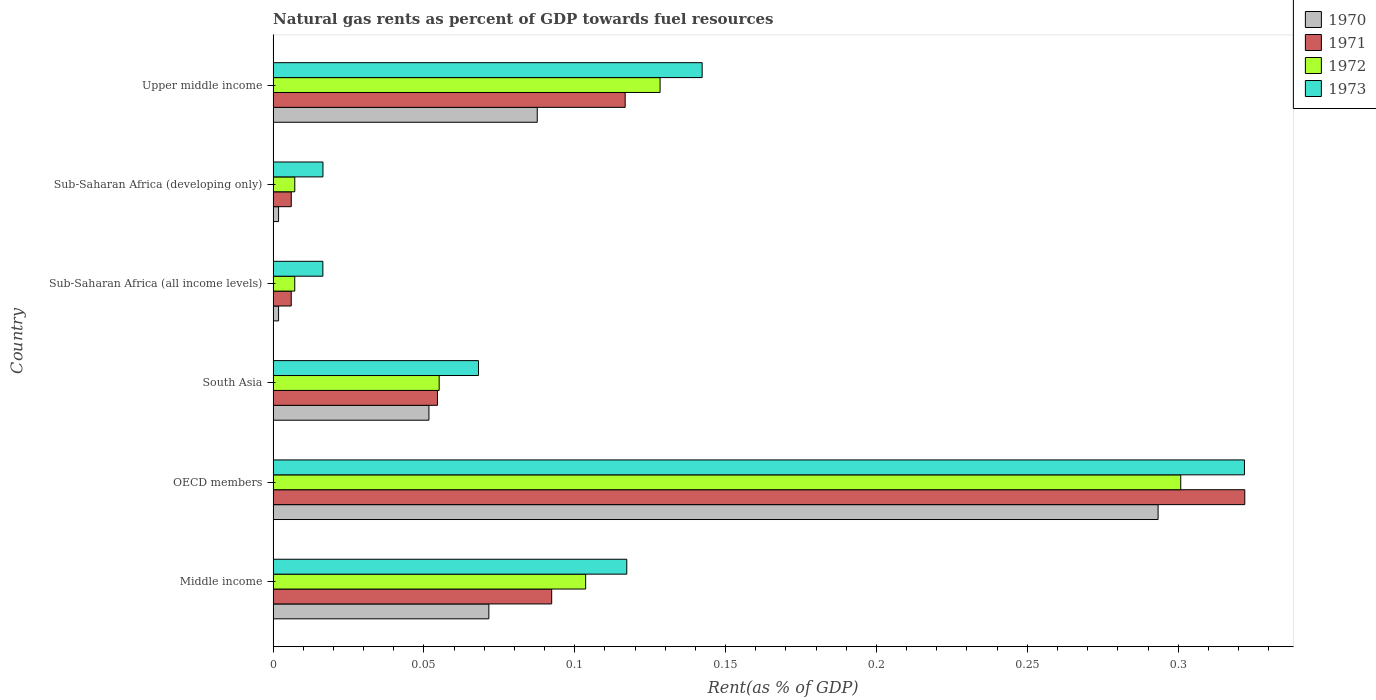Are the number of bars per tick equal to the number of legend labels?
Offer a terse response. Yes. Are the number of bars on each tick of the Y-axis equal?
Your response must be concise. Yes. How many bars are there on the 1st tick from the top?
Your response must be concise. 4. What is the label of the 2nd group of bars from the top?
Keep it short and to the point. Sub-Saharan Africa (developing only). What is the matural gas rent in 1972 in Sub-Saharan Africa (all income levels)?
Keep it short and to the point. 0.01. Across all countries, what is the maximum matural gas rent in 1971?
Keep it short and to the point. 0.32. Across all countries, what is the minimum matural gas rent in 1973?
Your answer should be compact. 0.02. In which country was the matural gas rent in 1973 minimum?
Ensure brevity in your answer.  Sub-Saharan Africa (all income levels). What is the total matural gas rent in 1973 in the graph?
Provide a short and direct response. 0.68. What is the difference between the matural gas rent in 1970 in OECD members and that in Sub-Saharan Africa (all income levels)?
Your answer should be very brief. 0.29. What is the difference between the matural gas rent in 1972 in South Asia and the matural gas rent in 1971 in Middle income?
Keep it short and to the point. -0.04. What is the average matural gas rent in 1971 per country?
Offer a terse response. 0.1. What is the difference between the matural gas rent in 1973 and matural gas rent in 1971 in Middle income?
Give a very brief answer. 0.02. In how many countries, is the matural gas rent in 1972 greater than 0.29 %?
Ensure brevity in your answer.  1. What is the ratio of the matural gas rent in 1971 in Sub-Saharan Africa (all income levels) to that in Upper middle income?
Provide a succinct answer. 0.05. Is the difference between the matural gas rent in 1973 in Sub-Saharan Africa (all income levels) and Sub-Saharan Africa (developing only) greater than the difference between the matural gas rent in 1971 in Sub-Saharan Africa (all income levels) and Sub-Saharan Africa (developing only)?
Make the answer very short. No. What is the difference between the highest and the second highest matural gas rent in 1970?
Make the answer very short. 0.21. What is the difference between the highest and the lowest matural gas rent in 1971?
Your answer should be very brief. 0.32. In how many countries, is the matural gas rent in 1970 greater than the average matural gas rent in 1970 taken over all countries?
Give a very brief answer. 2. Is the sum of the matural gas rent in 1972 in Middle income and Sub-Saharan Africa (developing only) greater than the maximum matural gas rent in 1971 across all countries?
Keep it short and to the point. No. What does the 2nd bar from the top in OECD members represents?
Provide a short and direct response. 1972. What does the 3rd bar from the bottom in OECD members represents?
Keep it short and to the point. 1972. Is it the case that in every country, the sum of the matural gas rent in 1971 and matural gas rent in 1970 is greater than the matural gas rent in 1972?
Provide a succinct answer. Yes. How many bars are there?
Offer a terse response. 24. Does the graph contain any zero values?
Your answer should be compact. No. Does the graph contain grids?
Offer a terse response. No. How many legend labels are there?
Your response must be concise. 4. What is the title of the graph?
Offer a very short reply. Natural gas rents as percent of GDP towards fuel resources. What is the label or title of the X-axis?
Your answer should be very brief. Rent(as % of GDP). What is the label or title of the Y-axis?
Your answer should be very brief. Country. What is the Rent(as % of GDP) in 1970 in Middle income?
Your response must be concise. 0.07. What is the Rent(as % of GDP) of 1971 in Middle income?
Keep it short and to the point. 0.09. What is the Rent(as % of GDP) of 1972 in Middle income?
Provide a succinct answer. 0.1. What is the Rent(as % of GDP) in 1973 in Middle income?
Offer a terse response. 0.12. What is the Rent(as % of GDP) in 1970 in OECD members?
Offer a terse response. 0.29. What is the Rent(as % of GDP) of 1971 in OECD members?
Provide a short and direct response. 0.32. What is the Rent(as % of GDP) in 1972 in OECD members?
Your response must be concise. 0.3. What is the Rent(as % of GDP) of 1973 in OECD members?
Give a very brief answer. 0.32. What is the Rent(as % of GDP) of 1970 in South Asia?
Your answer should be very brief. 0.05. What is the Rent(as % of GDP) in 1971 in South Asia?
Your answer should be compact. 0.05. What is the Rent(as % of GDP) of 1972 in South Asia?
Your response must be concise. 0.06. What is the Rent(as % of GDP) of 1973 in South Asia?
Give a very brief answer. 0.07. What is the Rent(as % of GDP) of 1970 in Sub-Saharan Africa (all income levels)?
Give a very brief answer. 0. What is the Rent(as % of GDP) of 1971 in Sub-Saharan Africa (all income levels)?
Keep it short and to the point. 0.01. What is the Rent(as % of GDP) in 1972 in Sub-Saharan Africa (all income levels)?
Give a very brief answer. 0.01. What is the Rent(as % of GDP) in 1973 in Sub-Saharan Africa (all income levels)?
Offer a very short reply. 0.02. What is the Rent(as % of GDP) in 1970 in Sub-Saharan Africa (developing only)?
Offer a very short reply. 0. What is the Rent(as % of GDP) of 1971 in Sub-Saharan Africa (developing only)?
Keep it short and to the point. 0.01. What is the Rent(as % of GDP) of 1972 in Sub-Saharan Africa (developing only)?
Ensure brevity in your answer.  0.01. What is the Rent(as % of GDP) in 1973 in Sub-Saharan Africa (developing only)?
Offer a very short reply. 0.02. What is the Rent(as % of GDP) in 1970 in Upper middle income?
Ensure brevity in your answer.  0.09. What is the Rent(as % of GDP) in 1971 in Upper middle income?
Keep it short and to the point. 0.12. What is the Rent(as % of GDP) in 1972 in Upper middle income?
Your response must be concise. 0.13. What is the Rent(as % of GDP) in 1973 in Upper middle income?
Provide a short and direct response. 0.14. Across all countries, what is the maximum Rent(as % of GDP) of 1970?
Your answer should be very brief. 0.29. Across all countries, what is the maximum Rent(as % of GDP) of 1971?
Offer a very short reply. 0.32. Across all countries, what is the maximum Rent(as % of GDP) of 1972?
Your answer should be compact. 0.3. Across all countries, what is the maximum Rent(as % of GDP) in 1973?
Ensure brevity in your answer.  0.32. Across all countries, what is the minimum Rent(as % of GDP) in 1970?
Your answer should be compact. 0. Across all countries, what is the minimum Rent(as % of GDP) of 1971?
Offer a very short reply. 0.01. Across all countries, what is the minimum Rent(as % of GDP) in 1972?
Your answer should be very brief. 0.01. Across all countries, what is the minimum Rent(as % of GDP) in 1973?
Make the answer very short. 0.02. What is the total Rent(as % of GDP) of 1970 in the graph?
Provide a succinct answer. 0.51. What is the total Rent(as % of GDP) in 1971 in the graph?
Provide a short and direct response. 0.6. What is the total Rent(as % of GDP) in 1972 in the graph?
Your answer should be very brief. 0.6. What is the total Rent(as % of GDP) in 1973 in the graph?
Ensure brevity in your answer.  0.68. What is the difference between the Rent(as % of GDP) in 1970 in Middle income and that in OECD members?
Your response must be concise. -0.22. What is the difference between the Rent(as % of GDP) of 1971 in Middle income and that in OECD members?
Give a very brief answer. -0.23. What is the difference between the Rent(as % of GDP) in 1972 in Middle income and that in OECD members?
Offer a very short reply. -0.2. What is the difference between the Rent(as % of GDP) of 1973 in Middle income and that in OECD members?
Your response must be concise. -0.2. What is the difference between the Rent(as % of GDP) of 1970 in Middle income and that in South Asia?
Your answer should be very brief. 0.02. What is the difference between the Rent(as % of GDP) in 1971 in Middle income and that in South Asia?
Provide a succinct answer. 0.04. What is the difference between the Rent(as % of GDP) of 1972 in Middle income and that in South Asia?
Make the answer very short. 0.05. What is the difference between the Rent(as % of GDP) in 1973 in Middle income and that in South Asia?
Keep it short and to the point. 0.05. What is the difference between the Rent(as % of GDP) of 1970 in Middle income and that in Sub-Saharan Africa (all income levels)?
Offer a terse response. 0.07. What is the difference between the Rent(as % of GDP) in 1971 in Middle income and that in Sub-Saharan Africa (all income levels)?
Your answer should be very brief. 0.09. What is the difference between the Rent(as % of GDP) of 1972 in Middle income and that in Sub-Saharan Africa (all income levels)?
Your answer should be very brief. 0.1. What is the difference between the Rent(as % of GDP) of 1973 in Middle income and that in Sub-Saharan Africa (all income levels)?
Make the answer very short. 0.1. What is the difference between the Rent(as % of GDP) of 1970 in Middle income and that in Sub-Saharan Africa (developing only)?
Provide a short and direct response. 0.07. What is the difference between the Rent(as % of GDP) in 1971 in Middle income and that in Sub-Saharan Africa (developing only)?
Make the answer very short. 0.09. What is the difference between the Rent(as % of GDP) in 1972 in Middle income and that in Sub-Saharan Africa (developing only)?
Your response must be concise. 0.1. What is the difference between the Rent(as % of GDP) of 1973 in Middle income and that in Sub-Saharan Africa (developing only)?
Your answer should be very brief. 0.1. What is the difference between the Rent(as % of GDP) in 1970 in Middle income and that in Upper middle income?
Your answer should be compact. -0.02. What is the difference between the Rent(as % of GDP) in 1971 in Middle income and that in Upper middle income?
Your answer should be compact. -0.02. What is the difference between the Rent(as % of GDP) of 1972 in Middle income and that in Upper middle income?
Offer a terse response. -0.02. What is the difference between the Rent(as % of GDP) in 1973 in Middle income and that in Upper middle income?
Provide a succinct answer. -0.03. What is the difference between the Rent(as % of GDP) in 1970 in OECD members and that in South Asia?
Offer a terse response. 0.24. What is the difference between the Rent(as % of GDP) in 1971 in OECD members and that in South Asia?
Offer a terse response. 0.27. What is the difference between the Rent(as % of GDP) of 1972 in OECD members and that in South Asia?
Provide a succinct answer. 0.25. What is the difference between the Rent(as % of GDP) of 1973 in OECD members and that in South Asia?
Offer a terse response. 0.25. What is the difference between the Rent(as % of GDP) in 1970 in OECD members and that in Sub-Saharan Africa (all income levels)?
Make the answer very short. 0.29. What is the difference between the Rent(as % of GDP) of 1971 in OECD members and that in Sub-Saharan Africa (all income levels)?
Give a very brief answer. 0.32. What is the difference between the Rent(as % of GDP) in 1972 in OECD members and that in Sub-Saharan Africa (all income levels)?
Make the answer very short. 0.29. What is the difference between the Rent(as % of GDP) of 1973 in OECD members and that in Sub-Saharan Africa (all income levels)?
Your answer should be very brief. 0.31. What is the difference between the Rent(as % of GDP) in 1970 in OECD members and that in Sub-Saharan Africa (developing only)?
Offer a terse response. 0.29. What is the difference between the Rent(as % of GDP) in 1971 in OECD members and that in Sub-Saharan Africa (developing only)?
Offer a very short reply. 0.32. What is the difference between the Rent(as % of GDP) in 1972 in OECD members and that in Sub-Saharan Africa (developing only)?
Your answer should be compact. 0.29. What is the difference between the Rent(as % of GDP) of 1973 in OECD members and that in Sub-Saharan Africa (developing only)?
Offer a terse response. 0.31. What is the difference between the Rent(as % of GDP) of 1970 in OECD members and that in Upper middle income?
Offer a very short reply. 0.21. What is the difference between the Rent(as % of GDP) in 1971 in OECD members and that in Upper middle income?
Provide a short and direct response. 0.21. What is the difference between the Rent(as % of GDP) of 1972 in OECD members and that in Upper middle income?
Your answer should be very brief. 0.17. What is the difference between the Rent(as % of GDP) of 1973 in OECD members and that in Upper middle income?
Keep it short and to the point. 0.18. What is the difference between the Rent(as % of GDP) of 1970 in South Asia and that in Sub-Saharan Africa (all income levels)?
Keep it short and to the point. 0.05. What is the difference between the Rent(as % of GDP) of 1971 in South Asia and that in Sub-Saharan Africa (all income levels)?
Provide a short and direct response. 0.05. What is the difference between the Rent(as % of GDP) of 1972 in South Asia and that in Sub-Saharan Africa (all income levels)?
Ensure brevity in your answer.  0.05. What is the difference between the Rent(as % of GDP) of 1973 in South Asia and that in Sub-Saharan Africa (all income levels)?
Your answer should be very brief. 0.05. What is the difference between the Rent(as % of GDP) of 1970 in South Asia and that in Sub-Saharan Africa (developing only)?
Give a very brief answer. 0.05. What is the difference between the Rent(as % of GDP) of 1971 in South Asia and that in Sub-Saharan Africa (developing only)?
Your answer should be very brief. 0.05. What is the difference between the Rent(as % of GDP) of 1972 in South Asia and that in Sub-Saharan Africa (developing only)?
Your answer should be very brief. 0.05. What is the difference between the Rent(as % of GDP) of 1973 in South Asia and that in Sub-Saharan Africa (developing only)?
Provide a short and direct response. 0.05. What is the difference between the Rent(as % of GDP) in 1970 in South Asia and that in Upper middle income?
Provide a succinct answer. -0.04. What is the difference between the Rent(as % of GDP) in 1971 in South Asia and that in Upper middle income?
Give a very brief answer. -0.06. What is the difference between the Rent(as % of GDP) in 1972 in South Asia and that in Upper middle income?
Provide a succinct answer. -0.07. What is the difference between the Rent(as % of GDP) of 1973 in South Asia and that in Upper middle income?
Give a very brief answer. -0.07. What is the difference between the Rent(as % of GDP) of 1971 in Sub-Saharan Africa (all income levels) and that in Sub-Saharan Africa (developing only)?
Make the answer very short. -0. What is the difference between the Rent(as % of GDP) in 1972 in Sub-Saharan Africa (all income levels) and that in Sub-Saharan Africa (developing only)?
Make the answer very short. -0. What is the difference between the Rent(as % of GDP) in 1973 in Sub-Saharan Africa (all income levels) and that in Sub-Saharan Africa (developing only)?
Your answer should be compact. -0. What is the difference between the Rent(as % of GDP) of 1970 in Sub-Saharan Africa (all income levels) and that in Upper middle income?
Give a very brief answer. -0.09. What is the difference between the Rent(as % of GDP) of 1971 in Sub-Saharan Africa (all income levels) and that in Upper middle income?
Your response must be concise. -0.11. What is the difference between the Rent(as % of GDP) of 1972 in Sub-Saharan Africa (all income levels) and that in Upper middle income?
Offer a very short reply. -0.12. What is the difference between the Rent(as % of GDP) of 1973 in Sub-Saharan Africa (all income levels) and that in Upper middle income?
Provide a short and direct response. -0.13. What is the difference between the Rent(as % of GDP) of 1970 in Sub-Saharan Africa (developing only) and that in Upper middle income?
Provide a succinct answer. -0.09. What is the difference between the Rent(as % of GDP) in 1971 in Sub-Saharan Africa (developing only) and that in Upper middle income?
Offer a very short reply. -0.11. What is the difference between the Rent(as % of GDP) of 1972 in Sub-Saharan Africa (developing only) and that in Upper middle income?
Your answer should be very brief. -0.12. What is the difference between the Rent(as % of GDP) in 1973 in Sub-Saharan Africa (developing only) and that in Upper middle income?
Offer a terse response. -0.13. What is the difference between the Rent(as % of GDP) in 1970 in Middle income and the Rent(as % of GDP) in 1971 in OECD members?
Offer a terse response. -0.25. What is the difference between the Rent(as % of GDP) in 1970 in Middle income and the Rent(as % of GDP) in 1972 in OECD members?
Your answer should be very brief. -0.23. What is the difference between the Rent(as % of GDP) in 1970 in Middle income and the Rent(as % of GDP) in 1973 in OECD members?
Make the answer very short. -0.25. What is the difference between the Rent(as % of GDP) in 1971 in Middle income and the Rent(as % of GDP) in 1972 in OECD members?
Give a very brief answer. -0.21. What is the difference between the Rent(as % of GDP) in 1971 in Middle income and the Rent(as % of GDP) in 1973 in OECD members?
Keep it short and to the point. -0.23. What is the difference between the Rent(as % of GDP) in 1972 in Middle income and the Rent(as % of GDP) in 1973 in OECD members?
Ensure brevity in your answer.  -0.22. What is the difference between the Rent(as % of GDP) of 1970 in Middle income and the Rent(as % of GDP) of 1971 in South Asia?
Provide a succinct answer. 0.02. What is the difference between the Rent(as % of GDP) in 1970 in Middle income and the Rent(as % of GDP) in 1972 in South Asia?
Your response must be concise. 0.02. What is the difference between the Rent(as % of GDP) in 1970 in Middle income and the Rent(as % of GDP) in 1973 in South Asia?
Make the answer very short. 0. What is the difference between the Rent(as % of GDP) in 1971 in Middle income and the Rent(as % of GDP) in 1972 in South Asia?
Provide a short and direct response. 0.04. What is the difference between the Rent(as % of GDP) in 1971 in Middle income and the Rent(as % of GDP) in 1973 in South Asia?
Your answer should be very brief. 0.02. What is the difference between the Rent(as % of GDP) in 1972 in Middle income and the Rent(as % of GDP) in 1973 in South Asia?
Provide a succinct answer. 0.04. What is the difference between the Rent(as % of GDP) of 1970 in Middle income and the Rent(as % of GDP) of 1971 in Sub-Saharan Africa (all income levels)?
Your answer should be compact. 0.07. What is the difference between the Rent(as % of GDP) in 1970 in Middle income and the Rent(as % of GDP) in 1972 in Sub-Saharan Africa (all income levels)?
Make the answer very short. 0.06. What is the difference between the Rent(as % of GDP) of 1970 in Middle income and the Rent(as % of GDP) of 1973 in Sub-Saharan Africa (all income levels)?
Make the answer very short. 0.06. What is the difference between the Rent(as % of GDP) in 1971 in Middle income and the Rent(as % of GDP) in 1972 in Sub-Saharan Africa (all income levels)?
Make the answer very short. 0.09. What is the difference between the Rent(as % of GDP) in 1971 in Middle income and the Rent(as % of GDP) in 1973 in Sub-Saharan Africa (all income levels)?
Offer a terse response. 0.08. What is the difference between the Rent(as % of GDP) in 1972 in Middle income and the Rent(as % of GDP) in 1973 in Sub-Saharan Africa (all income levels)?
Provide a succinct answer. 0.09. What is the difference between the Rent(as % of GDP) in 1970 in Middle income and the Rent(as % of GDP) in 1971 in Sub-Saharan Africa (developing only)?
Provide a short and direct response. 0.07. What is the difference between the Rent(as % of GDP) in 1970 in Middle income and the Rent(as % of GDP) in 1972 in Sub-Saharan Africa (developing only)?
Your answer should be compact. 0.06. What is the difference between the Rent(as % of GDP) of 1970 in Middle income and the Rent(as % of GDP) of 1973 in Sub-Saharan Africa (developing only)?
Your answer should be very brief. 0.06. What is the difference between the Rent(as % of GDP) of 1971 in Middle income and the Rent(as % of GDP) of 1972 in Sub-Saharan Africa (developing only)?
Provide a succinct answer. 0.09. What is the difference between the Rent(as % of GDP) of 1971 in Middle income and the Rent(as % of GDP) of 1973 in Sub-Saharan Africa (developing only)?
Keep it short and to the point. 0.08. What is the difference between the Rent(as % of GDP) in 1972 in Middle income and the Rent(as % of GDP) in 1973 in Sub-Saharan Africa (developing only)?
Offer a terse response. 0.09. What is the difference between the Rent(as % of GDP) of 1970 in Middle income and the Rent(as % of GDP) of 1971 in Upper middle income?
Ensure brevity in your answer.  -0.05. What is the difference between the Rent(as % of GDP) of 1970 in Middle income and the Rent(as % of GDP) of 1972 in Upper middle income?
Provide a succinct answer. -0.06. What is the difference between the Rent(as % of GDP) in 1970 in Middle income and the Rent(as % of GDP) in 1973 in Upper middle income?
Offer a very short reply. -0.07. What is the difference between the Rent(as % of GDP) of 1971 in Middle income and the Rent(as % of GDP) of 1972 in Upper middle income?
Offer a very short reply. -0.04. What is the difference between the Rent(as % of GDP) of 1971 in Middle income and the Rent(as % of GDP) of 1973 in Upper middle income?
Keep it short and to the point. -0.05. What is the difference between the Rent(as % of GDP) of 1972 in Middle income and the Rent(as % of GDP) of 1973 in Upper middle income?
Offer a terse response. -0.04. What is the difference between the Rent(as % of GDP) in 1970 in OECD members and the Rent(as % of GDP) in 1971 in South Asia?
Give a very brief answer. 0.24. What is the difference between the Rent(as % of GDP) of 1970 in OECD members and the Rent(as % of GDP) of 1972 in South Asia?
Make the answer very short. 0.24. What is the difference between the Rent(as % of GDP) of 1970 in OECD members and the Rent(as % of GDP) of 1973 in South Asia?
Offer a terse response. 0.23. What is the difference between the Rent(as % of GDP) in 1971 in OECD members and the Rent(as % of GDP) in 1972 in South Asia?
Your response must be concise. 0.27. What is the difference between the Rent(as % of GDP) in 1971 in OECD members and the Rent(as % of GDP) in 1973 in South Asia?
Your answer should be very brief. 0.25. What is the difference between the Rent(as % of GDP) of 1972 in OECD members and the Rent(as % of GDP) of 1973 in South Asia?
Your answer should be compact. 0.23. What is the difference between the Rent(as % of GDP) in 1970 in OECD members and the Rent(as % of GDP) in 1971 in Sub-Saharan Africa (all income levels)?
Offer a terse response. 0.29. What is the difference between the Rent(as % of GDP) in 1970 in OECD members and the Rent(as % of GDP) in 1972 in Sub-Saharan Africa (all income levels)?
Make the answer very short. 0.29. What is the difference between the Rent(as % of GDP) of 1970 in OECD members and the Rent(as % of GDP) of 1973 in Sub-Saharan Africa (all income levels)?
Make the answer very short. 0.28. What is the difference between the Rent(as % of GDP) of 1971 in OECD members and the Rent(as % of GDP) of 1972 in Sub-Saharan Africa (all income levels)?
Your answer should be very brief. 0.31. What is the difference between the Rent(as % of GDP) of 1971 in OECD members and the Rent(as % of GDP) of 1973 in Sub-Saharan Africa (all income levels)?
Give a very brief answer. 0.31. What is the difference between the Rent(as % of GDP) of 1972 in OECD members and the Rent(as % of GDP) of 1973 in Sub-Saharan Africa (all income levels)?
Offer a terse response. 0.28. What is the difference between the Rent(as % of GDP) in 1970 in OECD members and the Rent(as % of GDP) in 1971 in Sub-Saharan Africa (developing only)?
Give a very brief answer. 0.29. What is the difference between the Rent(as % of GDP) of 1970 in OECD members and the Rent(as % of GDP) of 1972 in Sub-Saharan Africa (developing only)?
Give a very brief answer. 0.29. What is the difference between the Rent(as % of GDP) in 1970 in OECD members and the Rent(as % of GDP) in 1973 in Sub-Saharan Africa (developing only)?
Provide a short and direct response. 0.28. What is the difference between the Rent(as % of GDP) in 1971 in OECD members and the Rent(as % of GDP) in 1972 in Sub-Saharan Africa (developing only)?
Provide a succinct answer. 0.31. What is the difference between the Rent(as % of GDP) in 1971 in OECD members and the Rent(as % of GDP) in 1973 in Sub-Saharan Africa (developing only)?
Your response must be concise. 0.31. What is the difference between the Rent(as % of GDP) of 1972 in OECD members and the Rent(as % of GDP) of 1973 in Sub-Saharan Africa (developing only)?
Ensure brevity in your answer.  0.28. What is the difference between the Rent(as % of GDP) of 1970 in OECD members and the Rent(as % of GDP) of 1971 in Upper middle income?
Provide a succinct answer. 0.18. What is the difference between the Rent(as % of GDP) in 1970 in OECD members and the Rent(as % of GDP) in 1972 in Upper middle income?
Your answer should be compact. 0.17. What is the difference between the Rent(as % of GDP) of 1970 in OECD members and the Rent(as % of GDP) of 1973 in Upper middle income?
Provide a short and direct response. 0.15. What is the difference between the Rent(as % of GDP) in 1971 in OECD members and the Rent(as % of GDP) in 1972 in Upper middle income?
Keep it short and to the point. 0.19. What is the difference between the Rent(as % of GDP) of 1971 in OECD members and the Rent(as % of GDP) of 1973 in Upper middle income?
Make the answer very short. 0.18. What is the difference between the Rent(as % of GDP) in 1972 in OECD members and the Rent(as % of GDP) in 1973 in Upper middle income?
Your response must be concise. 0.16. What is the difference between the Rent(as % of GDP) of 1970 in South Asia and the Rent(as % of GDP) of 1971 in Sub-Saharan Africa (all income levels)?
Your answer should be very brief. 0.05. What is the difference between the Rent(as % of GDP) in 1970 in South Asia and the Rent(as % of GDP) in 1972 in Sub-Saharan Africa (all income levels)?
Offer a very short reply. 0.04. What is the difference between the Rent(as % of GDP) of 1970 in South Asia and the Rent(as % of GDP) of 1973 in Sub-Saharan Africa (all income levels)?
Make the answer very short. 0.04. What is the difference between the Rent(as % of GDP) in 1971 in South Asia and the Rent(as % of GDP) in 1972 in Sub-Saharan Africa (all income levels)?
Your response must be concise. 0.05. What is the difference between the Rent(as % of GDP) in 1971 in South Asia and the Rent(as % of GDP) in 1973 in Sub-Saharan Africa (all income levels)?
Make the answer very short. 0.04. What is the difference between the Rent(as % of GDP) of 1972 in South Asia and the Rent(as % of GDP) of 1973 in Sub-Saharan Africa (all income levels)?
Provide a succinct answer. 0.04. What is the difference between the Rent(as % of GDP) in 1970 in South Asia and the Rent(as % of GDP) in 1971 in Sub-Saharan Africa (developing only)?
Make the answer very short. 0.05. What is the difference between the Rent(as % of GDP) of 1970 in South Asia and the Rent(as % of GDP) of 1972 in Sub-Saharan Africa (developing only)?
Your answer should be compact. 0.04. What is the difference between the Rent(as % of GDP) in 1970 in South Asia and the Rent(as % of GDP) in 1973 in Sub-Saharan Africa (developing only)?
Offer a terse response. 0.04. What is the difference between the Rent(as % of GDP) of 1971 in South Asia and the Rent(as % of GDP) of 1972 in Sub-Saharan Africa (developing only)?
Your response must be concise. 0.05. What is the difference between the Rent(as % of GDP) in 1971 in South Asia and the Rent(as % of GDP) in 1973 in Sub-Saharan Africa (developing only)?
Make the answer very short. 0.04. What is the difference between the Rent(as % of GDP) in 1972 in South Asia and the Rent(as % of GDP) in 1973 in Sub-Saharan Africa (developing only)?
Offer a very short reply. 0.04. What is the difference between the Rent(as % of GDP) in 1970 in South Asia and the Rent(as % of GDP) in 1971 in Upper middle income?
Offer a very short reply. -0.07. What is the difference between the Rent(as % of GDP) of 1970 in South Asia and the Rent(as % of GDP) of 1972 in Upper middle income?
Offer a terse response. -0.08. What is the difference between the Rent(as % of GDP) in 1970 in South Asia and the Rent(as % of GDP) in 1973 in Upper middle income?
Ensure brevity in your answer.  -0.09. What is the difference between the Rent(as % of GDP) in 1971 in South Asia and the Rent(as % of GDP) in 1972 in Upper middle income?
Ensure brevity in your answer.  -0.07. What is the difference between the Rent(as % of GDP) of 1971 in South Asia and the Rent(as % of GDP) of 1973 in Upper middle income?
Offer a terse response. -0.09. What is the difference between the Rent(as % of GDP) of 1972 in South Asia and the Rent(as % of GDP) of 1973 in Upper middle income?
Keep it short and to the point. -0.09. What is the difference between the Rent(as % of GDP) of 1970 in Sub-Saharan Africa (all income levels) and the Rent(as % of GDP) of 1971 in Sub-Saharan Africa (developing only)?
Provide a short and direct response. -0. What is the difference between the Rent(as % of GDP) of 1970 in Sub-Saharan Africa (all income levels) and the Rent(as % of GDP) of 1972 in Sub-Saharan Africa (developing only)?
Give a very brief answer. -0.01. What is the difference between the Rent(as % of GDP) in 1970 in Sub-Saharan Africa (all income levels) and the Rent(as % of GDP) in 1973 in Sub-Saharan Africa (developing only)?
Offer a terse response. -0.01. What is the difference between the Rent(as % of GDP) in 1971 in Sub-Saharan Africa (all income levels) and the Rent(as % of GDP) in 1972 in Sub-Saharan Africa (developing only)?
Your answer should be very brief. -0. What is the difference between the Rent(as % of GDP) of 1971 in Sub-Saharan Africa (all income levels) and the Rent(as % of GDP) of 1973 in Sub-Saharan Africa (developing only)?
Provide a short and direct response. -0.01. What is the difference between the Rent(as % of GDP) of 1972 in Sub-Saharan Africa (all income levels) and the Rent(as % of GDP) of 1973 in Sub-Saharan Africa (developing only)?
Provide a succinct answer. -0.01. What is the difference between the Rent(as % of GDP) of 1970 in Sub-Saharan Africa (all income levels) and the Rent(as % of GDP) of 1971 in Upper middle income?
Keep it short and to the point. -0.11. What is the difference between the Rent(as % of GDP) of 1970 in Sub-Saharan Africa (all income levels) and the Rent(as % of GDP) of 1972 in Upper middle income?
Make the answer very short. -0.13. What is the difference between the Rent(as % of GDP) of 1970 in Sub-Saharan Africa (all income levels) and the Rent(as % of GDP) of 1973 in Upper middle income?
Provide a short and direct response. -0.14. What is the difference between the Rent(as % of GDP) of 1971 in Sub-Saharan Africa (all income levels) and the Rent(as % of GDP) of 1972 in Upper middle income?
Your response must be concise. -0.12. What is the difference between the Rent(as % of GDP) of 1971 in Sub-Saharan Africa (all income levels) and the Rent(as % of GDP) of 1973 in Upper middle income?
Provide a short and direct response. -0.14. What is the difference between the Rent(as % of GDP) of 1972 in Sub-Saharan Africa (all income levels) and the Rent(as % of GDP) of 1973 in Upper middle income?
Make the answer very short. -0.14. What is the difference between the Rent(as % of GDP) of 1970 in Sub-Saharan Africa (developing only) and the Rent(as % of GDP) of 1971 in Upper middle income?
Offer a terse response. -0.11. What is the difference between the Rent(as % of GDP) of 1970 in Sub-Saharan Africa (developing only) and the Rent(as % of GDP) of 1972 in Upper middle income?
Provide a short and direct response. -0.13. What is the difference between the Rent(as % of GDP) in 1970 in Sub-Saharan Africa (developing only) and the Rent(as % of GDP) in 1973 in Upper middle income?
Give a very brief answer. -0.14. What is the difference between the Rent(as % of GDP) of 1971 in Sub-Saharan Africa (developing only) and the Rent(as % of GDP) of 1972 in Upper middle income?
Provide a succinct answer. -0.12. What is the difference between the Rent(as % of GDP) in 1971 in Sub-Saharan Africa (developing only) and the Rent(as % of GDP) in 1973 in Upper middle income?
Your response must be concise. -0.14. What is the difference between the Rent(as % of GDP) in 1972 in Sub-Saharan Africa (developing only) and the Rent(as % of GDP) in 1973 in Upper middle income?
Make the answer very short. -0.14. What is the average Rent(as % of GDP) in 1970 per country?
Your response must be concise. 0.08. What is the average Rent(as % of GDP) in 1971 per country?
Your answer should be very brief. 0.1. What is the average Rent(as % of GDP) in 1972 per country?
Make the answer very short. 0.1. What is the average Rent(as % of GDP) in 1973 per country?
Offer a terse response. 0.11. What is the difference between the Rent(as % of GDP) in 1970 and Rent(as % of GDP) in 1971 in Middle income?
Provide a succinct answer. -0.02. What is the difference between the Rent(as % of GDP) of 1970 and Rent(as % of GDP) of 1972 in Middle income?
Provide a short and direct response. -0.03. What is the difference between the Rent(as % of GDP) in 1970 and Rent(as % of GDP) in 1973 in Middle income?
Your response must be concise. -0.05. What is the difference between the Rent(as % of GDP) in 1971 and Rent(as % of GDP) in 1972 in Middle income?
Your response must be concise. -0.01. What is the difference between the Rent(as % of GDP) in 1971 and Rent(as % of GDP) in 1973 in Middle income?
Provide a succinct answer. -0.02. What is the difference between the Rent(as % of GDP) in 1972 and Rent(as % of GDP) in 1973 in Middle income?
Offer a very short reply. -0.01. What is the difference between the Rent(as % of GDP) in 1970 and Rent(as % of GDP) in 1971 in OECD members?
Your answer should be compact. -0.03. What is the difference between the Rent(as % of GDP) in 1970 and Rent(as % of GDP) in 1972 in OECD members?
Ensure brevity in your answer.  -0.01. What is the difference between the Rent(as % of GDP) in 1970 and Rent(as % of GDP) in 1973 in OECD members?
Provide a succinct answer. -0.03. What is the difference between the Rent(as % of GDP) in 1971 and Rent(as % of GDP) in 1972 in OECD members?
Offer a very short reply. 0.02. What is the difference between the Rent(as % of GDP) in 1972 and Rent(as % of GDP) in 1973 in OECD members?
Ensure brevity in your answer.  -0.02. What is the difference between the Rent(as % of GDP) in 1970 and Rent(as % of GDP) in 1971 in South Asia?
Ensure brevity in your answer.  -0. What is the difference between the Rent(as % of GDP) in 1970 and Rent(as % of GDP) in 1972 in South Asia?
Provide a succinct answer. -0. What is the difference between the Rent(as % of GDP) in 1970 and Rent(as % of GDP) in 1973 in South Asia?
Give a very brief answer. -0.02. What is the difference between the Rent(as % of GDP) in 1971 and Rent(as % of GDP) in 1972 in South Asia?
Your answer should be very brief. -0. What is the difference between the Rent(as % of GDP) in 1971 and Rent(as % of GDP) in 1973 in South Asia?
Offer a terse response. -0.01. What is the difference between the Rent(as % of GDP) of 1972 and Rent(as % of GDP) of 1973 in South Asia?
Keep it short and to the point. -0.01. What is the difference between the Rent(as % of GDP) of 1970 and Rent(as % of GDP) of 1971 in Sub-Saharan Africa (all income levels)?
Ensure brevity in your answer.  -0. What is the difference between the Rent(as % of GDP) of 1970 and Rent(as % of GDP) of 1972 in Sub-Saharan Africa (all income levels)?
Ensure brevity in your answer.  -0.01. What is the difference between the Rent(as % of GDP) in 1970 and Rent(as % of GDP) in 1973 in Sub-Saharan Africa (all income levels)?
Your answer should be compact. -0.01. What is the difference between the Rent(as % of GDP) in 1971 and Rent(as % of GDP) in 1972 in Sub-Saharan Africa (all income levels)?
Your answer should be very brief. -0. What is the difference between the Rent(as % of GDP) in 1971 and Rent(as % of GDP) in 1973 in Sub-Saharan Africa (all income levels)?
Ensure brevity in your answer.  -0.01. What is the difference between the Rent(as % of GDP) of 1972 and Rent(as % of GDP) of 1973 in Sub-Saharan Africa (all income levels)?
Keep it short and to the point. -0.01. What is the difference between the Rent(as % of GDP) of 1970 and Rent(as % of GDP) of 1971 in Sub-Saharan Africa (developing only)?
Your answer should be compact. -0. What is the difference between the Rent(as % of GDP) of 1970 and Rent(as % of GDP) of 1972 in Sub-Saharan Africa (developing only)?
Keep it short and to the point. -0.01. What is the difference between the Rent(as % of GDP) of 1970 and Rent(as % of GDP) of 1973 in Sub-Saharan Africa (developing only)?
Your response must be concise. -0.01. What is the difference between the Rent(as % of GDP) in 1971 and Rent(as % of GDP) in 1972 in Sub-Saharan Africa (developing only)?
Your answer should be very brief. -0. What is the difference between the Rent(as % of GDP) in 1971 and Rent(as % of GDP) in 1973 in Sub-Saharan Africa (developing only)?
Offer a terse response. -0.01. What is the difference between the Rent(as % of GDP) of 1972 and Rent(as % of GDP) of 1973 in Sub-Saharan Africa (developing only)?
Make the answer very short. -0.01. What is the difference between the Rent(as % of GDP) in 1970 and Rent(as % of GDP) in 1971 in Upper middle income?
Keep it short and to the point. -0.03. What is the difference between the Rent(as % of GDP) in 1970 and Rent(as % of GDP) in 1972 in Upper middle income?
Provide a succinct answer. -0.04. What is the difference between the Rent(as % of GDP) in 1970 and Rent(as % of GDP) in 1973 in Upper middle income?
Keep it short and to the point. -0.05. What is the difference between the Rent(as % of GDP) of 1971 and Rent(as % of GDP) of 1972 in Upper middle income?
Make the answer very short. -0.01. What is the difference between the Rent(as % of GDP) in 1971 and Rent(as % of GDP) in 1973 in Upper middle income?
Provide a succinct answer. -0.03. What is the difference between the Rent(as % of GDP) of 1972 and Rent(as % of GDP) of 1973 in Upper middle income?
Provide a succinct answer. -0.01. What is the ratio of the Rent(as % of GDP) in 1970 in Middle income to that in OECD members?
Your answer should be compact. 0.24. What is the ratio of the Rent(as % of GDP) of 1971 in Middle income to that in OECD members?
Ensure brevity in your answer.  0.29. What is the ratio of the Rent(as % of GDP) of 1972 in Middle income to that in OECD members?
Offer a very short reply. 0.34. What is the ratio of the Rent(as % of GDP) of 1973 in Middle income to that in OECD members?
Ensure brevity in your answer.  0.36. What is the ratio of the Rent(as % of GDP) of 1970 in Middle income to that in South Asia?
Ensure brevity in your answer.  1.38. What is the ratio of the Rent(as % of GDP) of 1971 in Middle income to that in South Asia?
Offer a terse response. 1.69. What is the ratio of the Rent(as % of GDP) in 1972 in Middle income to that in South Asia?
Your answer should be very brief. 1.88. What is the ratio of the Rent(as % of GDP) in 1973 in Middle income to that in South Asia?
Your answer should be compact. 1.72. What is the ratio of the Rent(as % of GDP) in 1970 in Middle income to that in Sub-Saharan Africa (all income levels)?
Provide a succinct answer. 39.57. What is the ratio of the Rent(as % of GDP) in 1971 in Middle income to that in Sub-Saharan Africa (all income levels)?
Offer a terse response. 15.38. What is the ratio of the Rent(as % of GDP) of 1972 in Middle income to that in Sub-Saharan Africa (all income levels)?
Keep it short and to the point. 14.45. What is the ratio of the Rent(as % of GDP) in 1973 in Middle income to that in Sub-Saharan Africa (all income levels)?
Your answer should be compact. 7.11. What is the ratio of the Rent(as % of GDP) of 1970 in Middle income to that in Sub-Saharan Africa (developing only)?
Your response must be concise. 39.51. What is the ratio of the Rent(as % of GDP) in 1971 in Middle income to that in Sub-Saharan Africa (developing only)?
Offer a very short reply. 15.35. What is the ratio of the Rent(as % of GDP) in 1972 in Middle income to that in Sub-Saharan Africa (developing only)?
Provide a short and direct response. 14.42. What is the ratio of the Rent(as % of GDP) in 1973 in Middle income to that in Sub-Saharan Africa (developing only)?
Your answer should be very brief. 7.1. What is the ratio of the Rent(as % of GDP) of 1970 in Middle income to that in Upper middle income?
Make the answer very short. 0.82. What is the ratio of the Rent(as % of GDP) of 1971 in Middle income to that in Upper middle income?
Provide a succinct answer. 0.79. What is the ratio of the Rent(as % of GDP) in 1972 in Middle income to that in Upper middle income?
Your response must be concise. 0.81. What is the ratio of the Rent(as % of GDP) of 1973 in Middle income to that in Upper middle income?
Ensure brevity in your answer.  0.82. What is the ratio of the Rent(as % of GDP) of 1970 in OECD members to that in South Asia?
Provide a short and direct response. 5.68. What is the ratio of the Rent(as % of GDP) of 1971 in OECD members to that in South Asia?
Your answer should be very brief. 5.91. What is the ratio of the Rent(as % of GDP) in 1972 in OECD members to that in South Asia?
Provide a short and direct response. 5.47. What is the ratio of the Rent(as % of GDP) of 1973 in OECD members to that in South Asia?
Offer a terse response. 4.73. What is the ratio of the Rent(as % of GDP) of 1970 in OECD members to that in Sub-Saharan Africa (all income levels)?
Keep it short and to the point. 162.3. What is the ratio of the Rent(as % of GDP) in 1971 in OECD members to that in Sub-Saharan Africa (all income levels)?
Ensure brevity in your answer.  53.64. What is the ratio of the Rent(as % of GDP) of 1972 in OECD members to that in Sub-Saharan Africa (all income levels)?
Keep it short and to the point. 41.95. What is the ratio of the Rent(as % of GDP) of 1973 in OECD members to that in Sub-Saharan Africa (all income levels)?
Give a very brief answer. 19.52. What is the ratio of the Rent(as % of GDP) of 1970 in OECD members to that in Sub-Saharan Africa (developing only)?
Provide a short and direct response. 162.05. What is the ratio of the Rent(as % of GDP) of 1971 in OECD members to that in Sub-Saharan Africa (developing only)?
Offer a very short reply. 53.56. What is the ratio of the Rent(as % of GDP) of 1972 in OECD members to that in Sub-Saharan Africa (developing only)?
Your answer should be very brief. 41.89. What is the ratio of the Rent(as % of GDP) of 1973 in OECD members to that in Sub-Saharan Africa (developing only)?
Ensure brevity in your answer.  19.49. What is the ratio of the Rent(as % of GDP) of 1970 in OECD members to that in Upper middle income?
Your answer should be compact. 3.35. What is the ratio of the Rent(as % of GDP) of 1971 in OECD members to that in Upper middle income?
Give a very brief answer. 2.76. What is the ratio of the Rent(as % of GDP) in 1972 in OECD members to that in Upper middle income?
Keep it short and to the point. 2.35. What is the ratio of the Rent(as % of GDP) in 1973 in OECD members to that in Upper middle income?
Provide a short and direct response. 2.26. What is the ratio of the Rent(as % of GDP) of 1970 in South Asia to that in Sub-Saharan Africa (all income levels)?
Ensure brevity in your answer.  28.57. What is the ratio of the Rent(as % of GDP) in 1971 in South Asia to that in Sub-Saharan Africa (all income levels)?
Offer a very short reply. 9.07. What is the ratio of the Rent(as % of GDP) of 1972 in South Asia to that in Sub-Saharan Africa (all income levels)?
Your answer should be very brief. 7.67. What is the ratio of the Rent(as % of GDP) in 1973 in South Asia to that in Sub-Saharan Africa (all income levels)?
Ensure brevity in your answer.  4.13. What is the ratio of the Rent(as % of GDP) of 1970 in South Asia to that in Sub-Saharan Africa (developing only)?
Your answer should be compact. 28.53. What is the ratio of the Rent(as % of GDP) of 1971 in South Asia to that in Sub-Saharan Africa (developing only)?
Your answer should be compact. 9.06. What is the ratio of the Rent(as % of GDP) in 1972 in South Asia to that in Sub-Saharan Africa (developing only)?
Keep it short and to the point. 7.66. What is the ratio of the Rent(as % of GDP) in 1973 in South Asia to that in Sub-Saharan Africa (developing only)?
Give a very brief answer. 4.12. What is the ratio of the Rent(as % of GDP) in 1970 in South Asia to that in Upper middle income?
Give a very brief answer. 0.59. What is the ratio of the Rent(as % of GDP) of 1971 in South Asia to that in Upper middle income?
Offer a very short reply. 0.47. What is the ratio of the Rent(as % of GDP) in 1972 in South Asia to that in Upper middle income?
Your response must be concise. 0.43. What is the ratio of the Rent(as % of GDP) of 1973 in South Asia to that in Upper middle income?
Provide a short and direct response. 0.48. What is the ratio of the Rent(as % of GDP) in 1972 in Sub-Saharan Africa (all income levels) to that in Sub-Saharan Africa (developing only)?
Ensure brevity in your answer.  1. What is the ratio of the Rent(as % of GDP) in 1970 in Sub-Saharan Africa (all income levels) to that in Upper middle income?
Keep it short and to the point. 0.02. What is the ratio of the Rent(as % of GDP) of 1971 in Sub-Saharan Africa (all income levels) to that in Upper middle income?
Keep it short and to the point. 0.05. What is the ratio of the Rent(as % of GDP) of 1972 in Sub-Saharan Africa (all income levels) to that in Upper middle income?
Offer a very short reply. 0.06. What is the ratio of the Rent(as % of GDP) of 1973 in Sub-Saharan Africa (all income levels) to that in Upper middle income?
Your response must be concise. 0.12. What is the ratio of the Rent(as % of GDP) in 1970 in Sub-Saharan Africa (developing only) to that in Upper middle income?
Offer a very short reply. 0.02. What is the ratio of the Rent(as % of GDP) of 1971 in Sub-Saharan Africa (developing only) to that in Upper middle income?
Ensure brevity in your answer.  0.05. What is the ratio of the Rent(as % of GDP) of 1972 in Sub-Saharan Africa (developing only) to that in Upper middle income?
Make the answer very short. 0.06. What is the ratio of the Rent(as % of GDP) of 1973 in Sub-Saharan Africa (developing only) to that in Upper middle income?
Your response must be concise. 0.12. What is the difference between the highest and the second highest Rent(as % of GDP) in 1970?
Offer a very short reply. 0.21. What is the difference between the highest and the second highest Rent(as % of GDP) in 1971?
Provide a short and direct response. 0.21. What is the difference between the highest and the second highest Rent(as % of GDP) in 1972?
Offer a terse response. 0.17. What is the difference between the highest and the second highest Rent(as % of GDP) in 1973?
Your answer should be compact. 0.18. What is the difference between the highest and the lowest Rent(as % of GDP) of 1970?
Offer a very short reply. 0.29. What is the difference between the highest and the lowest Rent(as % of GDP) of 1971?
Your response must be concise. 0.32. What is the difference between the highest and the lowest Rent(as % of GDP) of 1972?
Offer a terse response. 0.29. What is the difference between the highest and the lowest Rent(as % of GDP) of 1973?
Offer a very short reply. 0.31. 